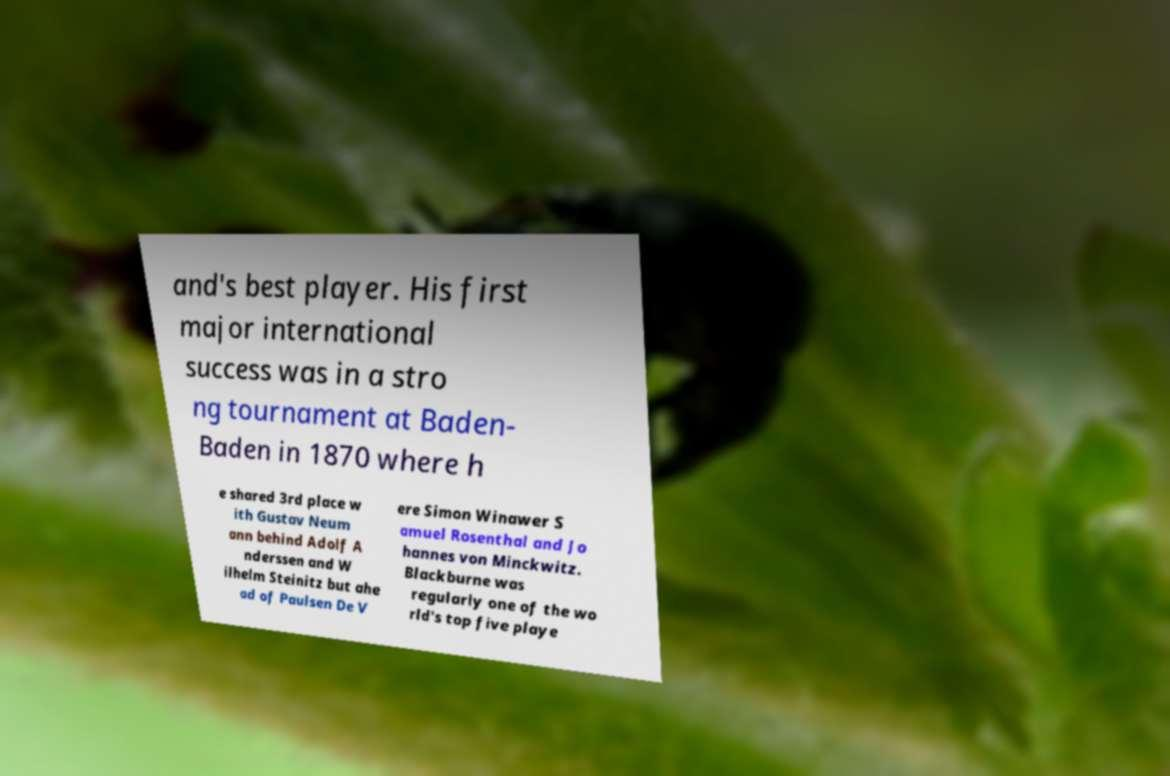Could you extract and type out the text from this image? and's best player. His first major international success was in a stro ng tournament at Baden- Baden in 1870 where h e shared 3rd place w ith Gustav Neum ann behind Adolf A nderssen and W ilhelm Steinitz but ahe ad of Paulsen De V ere Simon Winawer S amuel Rosenthal and Jo hannes von Minckwitz. Blackburne was regularly one of the wo rld's top five playe 